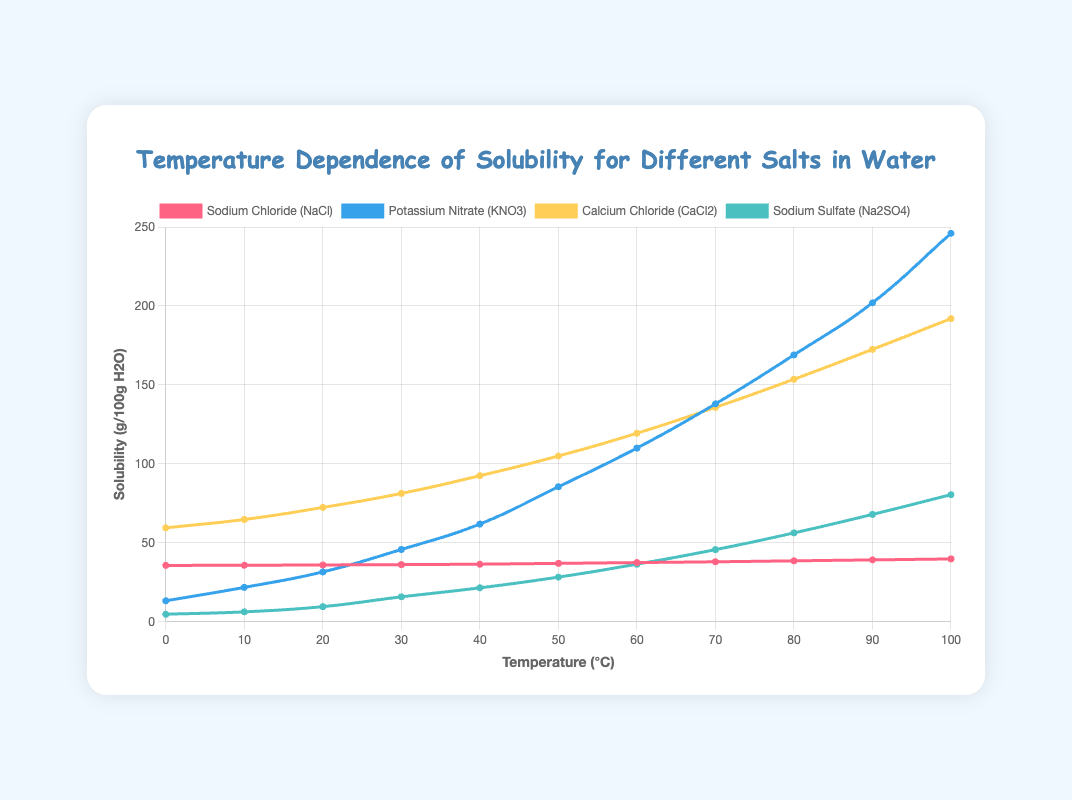Which salt has the highest solubility at 100°C? Look at the points at 100°C for each salt. The highest point corresponds to Potassium Nitrate (KNO3).
Answer: Potassium Nitrate (KNO3) At what temperature does Sodium Sulfate (Na2SO4) have a solubility of approximately 56.3 g/100g H2O? Trace the solubility value of 56.3 g/100g H2O horizontally and see where it intersects with Sodium Sulfate (Na2SO4) curve. It's at 80°C.
Answer: 80°C Compare the solubility of Sodium Chloride (NaCl) and Calcium Chloride (CaCl2) at 50°C. Which one is higher and by how much? At 50°C, the solubility of NaCl is 37.0 g/100g H2O and CaCl2 is 105.0 g/100g H2O. The difference is 105.0 - 37.0 = 68.0 g/100g H2O.
Answer: Calcium Chloride (CaCl2) by 68.0 g/100g H2O What is the average solubility of Potassium Nitrate (KNO3) between 20°C and 60°C? Find the solubility values at 20°C, 30°C, 40°C, 50°C, and 60°C for KNO3: (31.6 + 45.8 + 61.9 + 85.5 + 110.0) / 5 = 334.8 / 5 = 67.0 g/100g H2O.
Answer: 67.0 g/100g H2O Which salt shows the least change in solubility from 0°C to 100°C? Calculate the difference in solubility at 0°C and 100°C for each salt. Sodium Chloride (NaCl) changes from 35.7 g/100g H2O to 39.8 g/100g H2O, a change of 4.1 g/100g H2O, which is the least change.
Answer: Sodium Chloride (NaCl) If you mix Calcium Chloride (CaCl2) and Sodium Sulfate (Na2SO4) at 60°C, what is the total solubility? Add the solubility values at 60°C for CaCl2 (119.4 g/100g H2O) and Na2SO4 (36.5 g/100g H2O). The total is 119.4 + 36.5 = 155.9 g/100g H2O.
Answer: 155.9 g/100g H2O At what temperature does Potassium Nitrate (KNO3) first exceed a solubility of 50 g/100g H2O? Trace the solubility values for KNO3 and find the temperature where it first goes above 50.0 g/100g H2O, which is at 30°C.
Answer: 30°C 